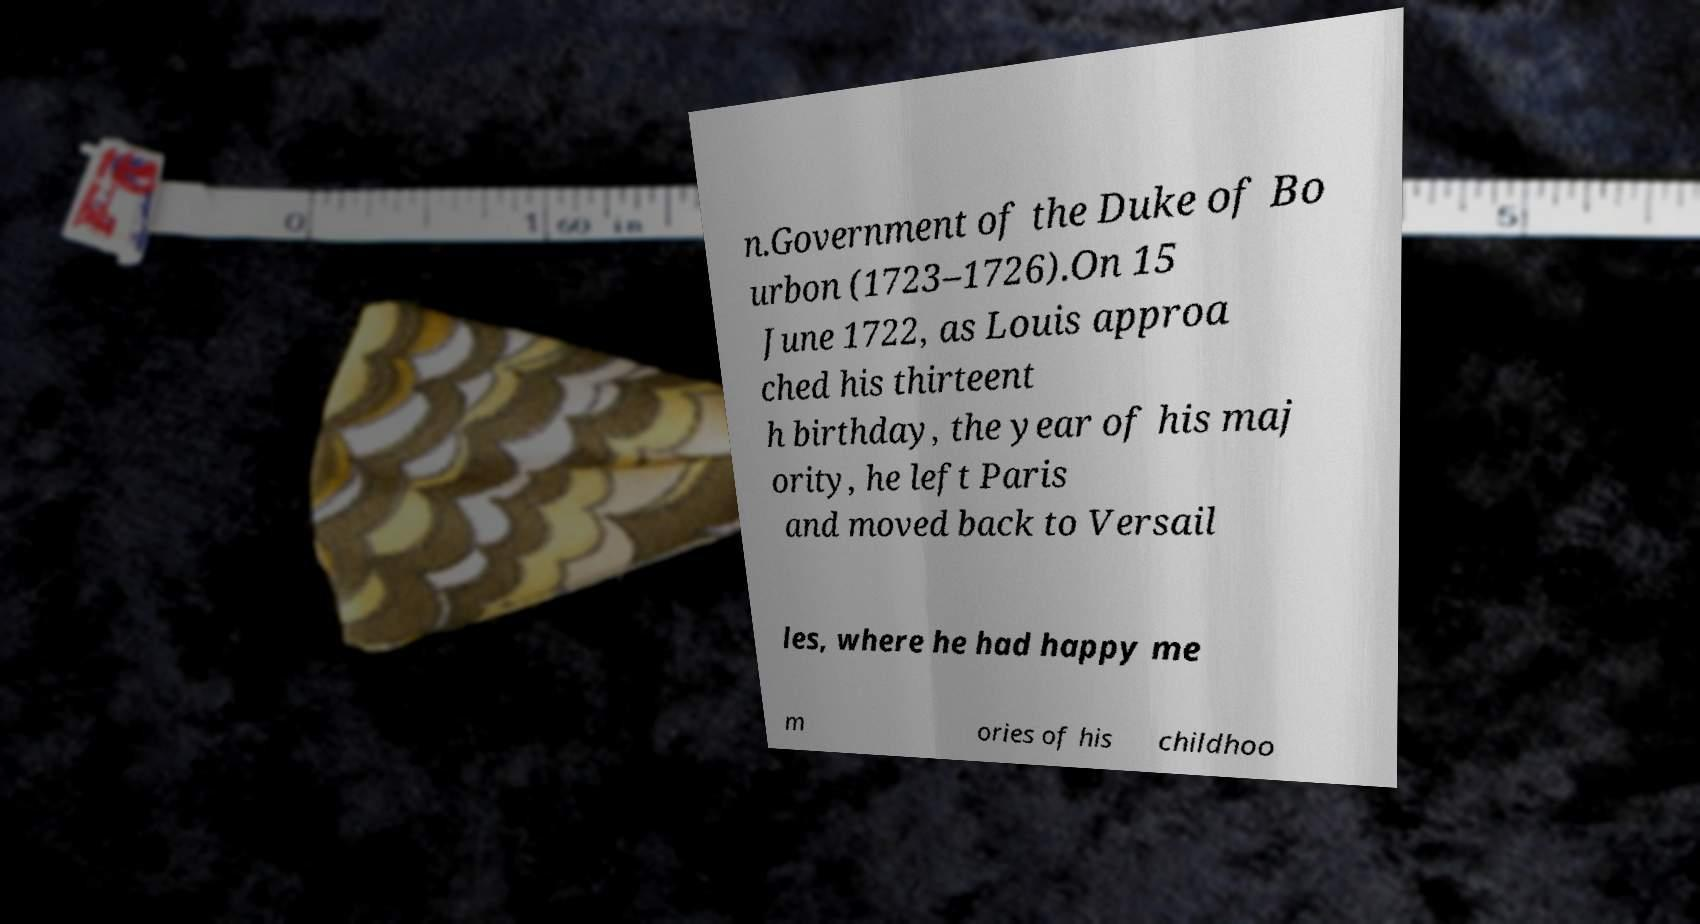Please read and relay the text visible in this image. What does it say? n.Government of the Duke of Bo urbon (1723–1726).On 15 June 1722, as Louis approa ched his thirteent h birthday, the year of his maj ority, he left Paris and moved back to Versail les, where he had happy me m ories of his childhoo 